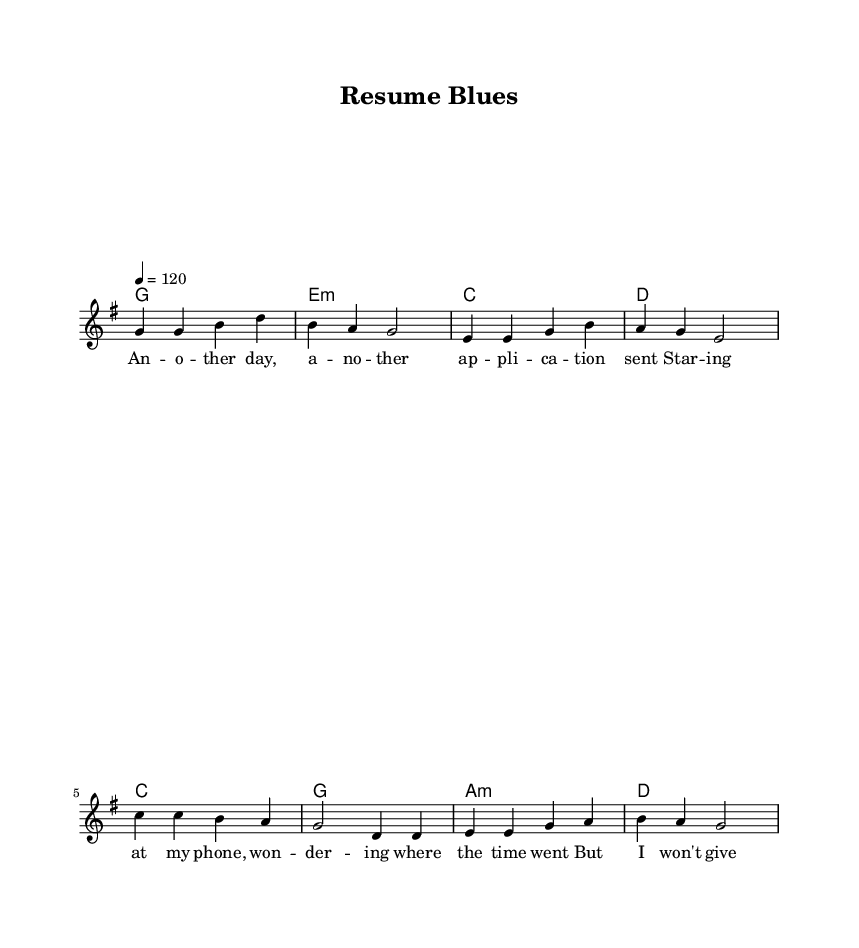What is the key signature of this music? The key signature is indicated at the beginning of the score. It shows one sharp (F#), which defines the music as being in the key of G major.
Answer: G major What is the time signature of this music? The time signature is clearly indicated in the score. It shows 4 over 4, meaning there are four beats in each measure, and a quarter note gets one beat.
Answer: 4/4 What is the tempo marking for the song? The tempo is indicated at the beginning of the score, describing the speed of the piece. The marking states 4 equals 120, meaning there are 120 beats per minute.
Answer: 120 How many measures are in the verse section? By counting the number of measures written for the verse in the score, we find there are four measures in total.
Answer: 4 What is the primary theme represented in the lyrics? The lyrics talk about the struggles and aspirations of young job seekers, focusing on perseverance despite challenges faced while seeking employment.
Answer: Job seeking What chord does the chorus start on? The chorus begins with the chord 'C' as indicated in the chord names section, confirming the initial harmony used during the chorus.
Answer: C What is the last lyric line in the verse? The last line of the verse is captured in the lyric section of the score, stating "where the time went," which completes the verse thoughts.
Answer: where the time went 